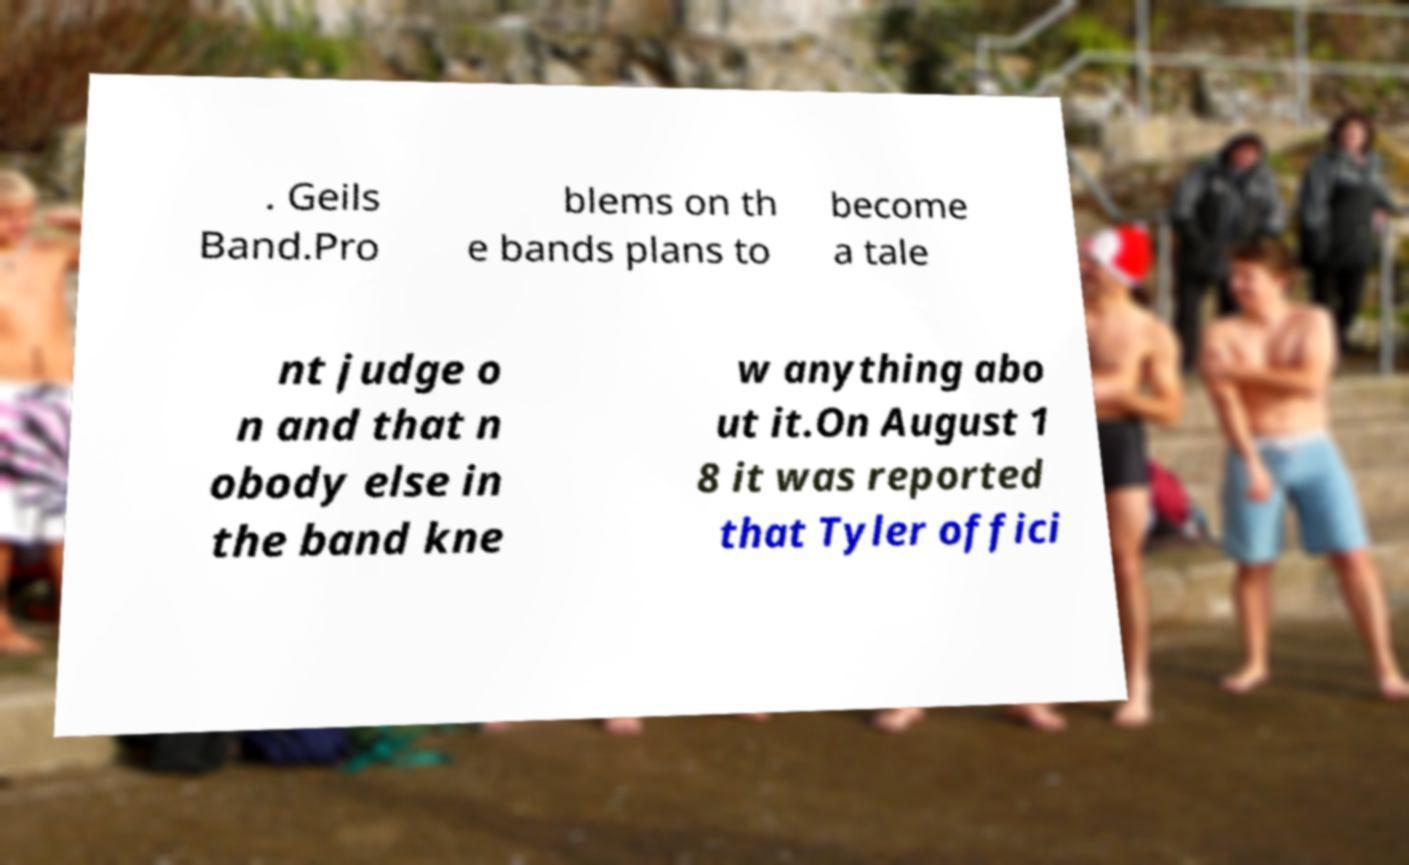Please read and relay the text visible in this image. What does it say? . Geils Band.Pro blems on th e bands plans to become a tale nt judge o n and that n obody else in the band kne w anything abo ut it.On August 1 8 it was reported that Tyler offici 